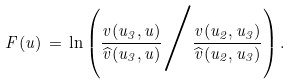<formula> <loc_0><loc_0><loc_500><loc_500>F ( u ) \, = \, \ln \left ( \frac { v ( u _ { 3 } , u ) } { \widehat { v } ( u _ { 3 } , u ) } \Big / \frac { v ( u _ { 2 } , u _ { 3 } ) } { \widehat { v } ( u _ { 2 } , u _ { 3 } ) } \right ) .</formula> 